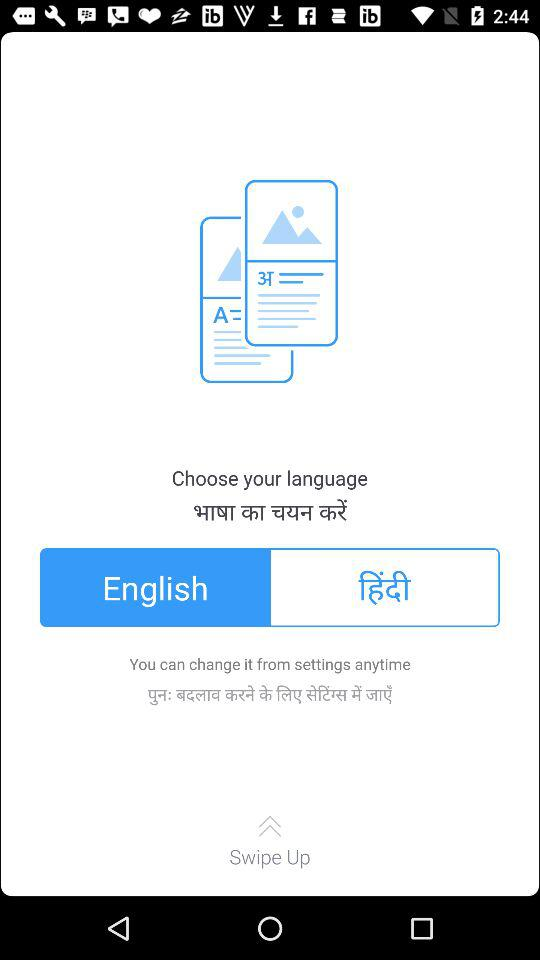Which language is selected? The selected language is "English". 